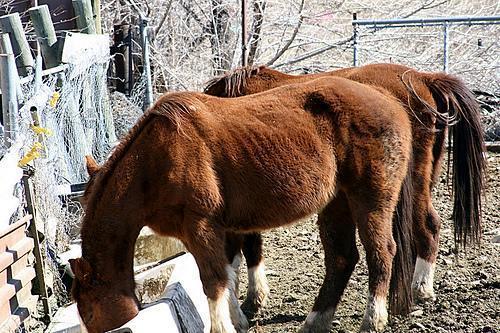How many horses eating?
Give a very brief answer. 2. 